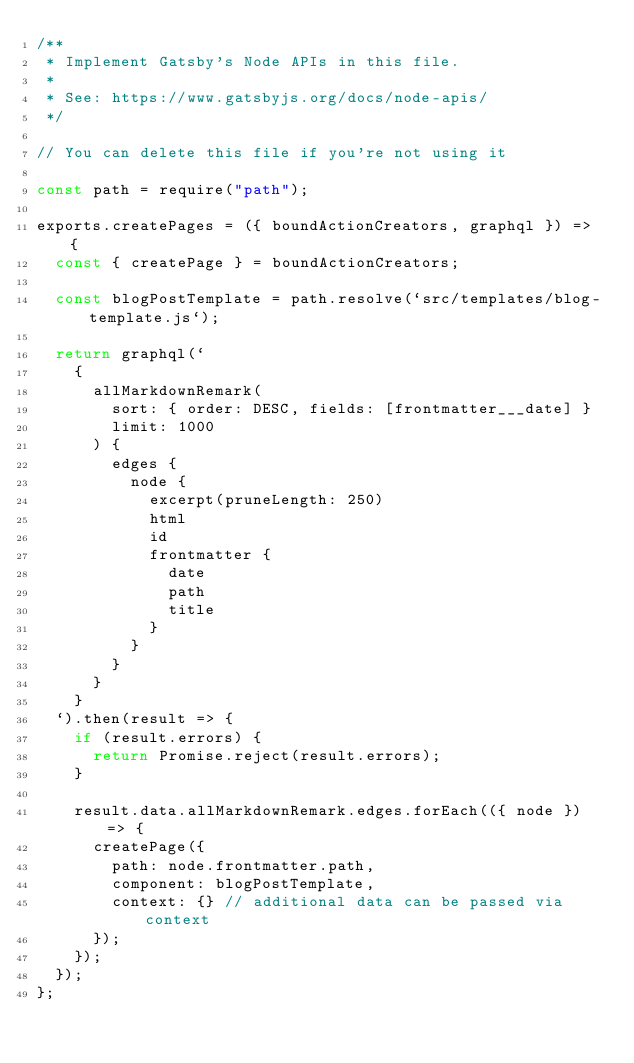Convert code to text. <code><loc_0><loc_0><loc_500><loc_500><_JavaScript_>/**
 * Implement Gatsby's Node APIs in this file.
 *
 * See: https://www.gatsbyjs.org/docs/node-apis/
 */

// You can delete this file if you're not using it

const path = require("path");

exports.createPages = ({ boundActionCreators, graphql }) => {
  const { createPage } = boundActionCreators;

  const blogPostTemplate = path.resolve(`src/templates/blog-template.js`);

  return graphql(`
    {
      allMarkdownRemark(
        sort: { order: DESC, fields: [frontmatter___date] }
        limit: 1000
      ) {
        edges {
          node {
            excerpt(pruneLength: 250)
            html
            id
            frontmatter {
              date
              path
              title
            }
          }
        }
      }
    }
  `).then(result => {
    if (result.errors) {
      return Promise.reject(result.errors);
    }

    result.data.allMarkdownRemark.edges.forEach(({ node }) => {
      createPage({
        path: node.frontmatter.path,
        component: blogPostTemplate,
        context: {} // additional data can be passed via context
      });
    });
  });
};
</code> 